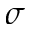<formula> <loc_0><loc_0><loc_500><loc_500>\sigma</formula> 